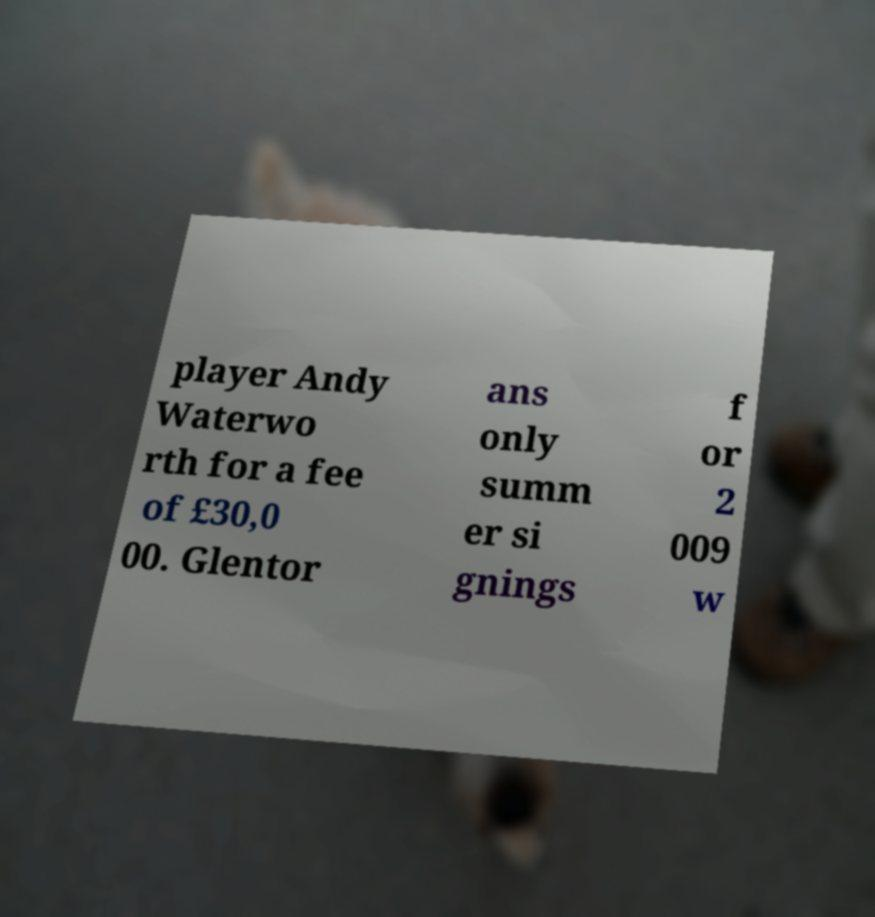Can you accurately transcribe the text from the provided image for me? player Andy Waterwo rth for a fee of £30,0 00. Glentor ans only summ er si gnings f or 2 009 w 